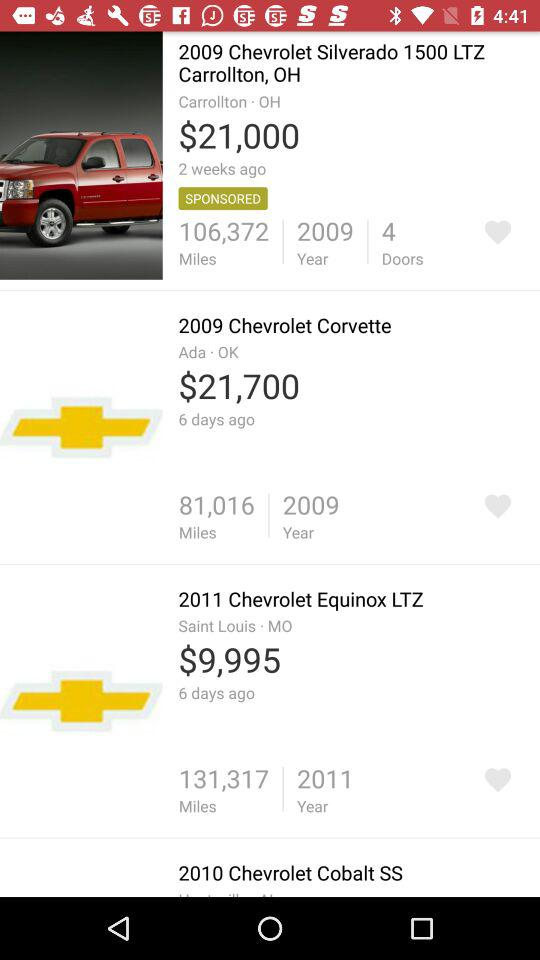What is the price of "2009 Chevrolet Silverado 1500 LTZ Carrollton, OH" car? The price of "2009 Chevrolet Silverado 1500 LTZ Carrollton, OH" car is 21,000 dollars. 